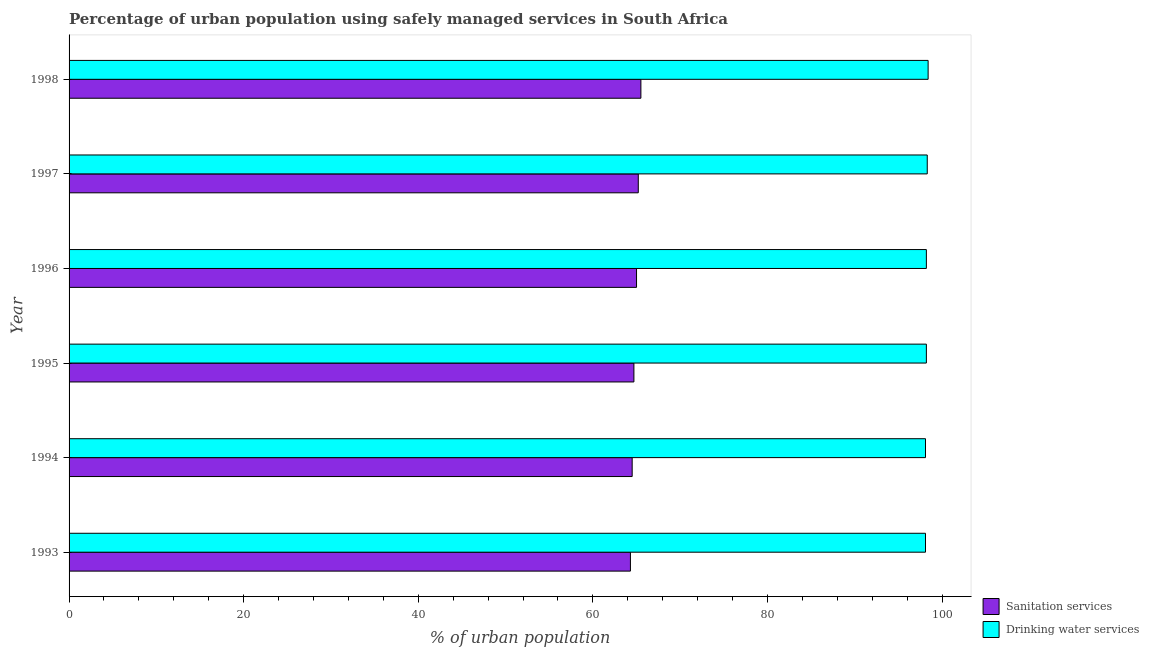How many different coloured bars are there?
Ensure brevity in your answer.  2. How many groups of bars are there?
Make the answer very short. 6. Are the number of bars on each tick of the Y-axis equal?
Offer a very short reply. Yes. How many bars are there on the 3rd tick from the bottom?
Provide a succinct answer. 2. What is the percentage of urban population who used sanitation services in 1998?
Ensure brevity in your answer.  65.5. Across all years, what is the maximum percentage of urban population who used sanitation services?
Your answer should be compact. 65.5. Across all years, what is the minimum percentage of urban population who used sanitation services?
Your answer should be very brief. 64.3. In which year was the percentage of urban population who used drinking water services maximum?
Offer a very short reply. 1998. In which year was the percentage of urban population who used sanitation services minimum?
Ensure brevity in your answer.  1993. What is the total percentage of urban population who used sanitation services in the graph?
Ensure brevity in your answer.  389.2. What is the difference between the percentage of urban population who used sanitation services in 1995 and the percentage of urban population who used drinking water services in 1996?
Make the answer very short. -33.5. What is the average percentage of urban population who used sanitation services per year?
Your answer should be very brief. 64.87. In the year 1996, what is the difference between the percentage of urban population who used sanitation services and percentage of urban population who used drinking water services?
Offer a terse response. -33.2. Is the difference between the percentage of urban population who used sanitation services in 1993 and 1998 greater than the difference between the percentage of urban population who used drinking water services in 1993 and 1998?
Your answer should be very brief. No. What is the difference between the highest and the second highest percentage of urban population who used drinking water services?
Provide a succinct answer. 0.1. What is the difference between the highest and the lowest percentage of urban population who used drinking water services?
Offer a terse response. 0.3. In how many years, is the percentage of urban population who used sanitation services greater than the average percentage of urban population who used sanitation services taken over all years?
Offer a very short reply. 3. Is the sum of the percentage of urban population who used drinking water services in 1994 and 1997 greater than the maximum percentage of urban population who used sanitation services across all years?
Your response must be concise. Yes. What does the 1st bar from the top in 1993 represents?
Provide a succinct answer. Drinking water services. What does the 2nd bar from the bottom in 1997 represents?
Your answer should be very brief. Drinking water services. How many bars are there?
Your answer should be compact. 12. How many years are there in the graph?
Your answer should be very brief. 6. Are the values on the major ticks of X-axis written in scientific E-notation?
Ensure brevity in your answer.  No. How many legend labels are there?
Your response must be concise. 2. What is the title of the graph?
Ensure brevity in your answer.  Percentage of urban population using safely managed services in South Africa. Does "Imports" appear as one of the legend labels in the graph?
Your answer should be very brief. No. What is the label or title of the X-axis?
Make the answer very short. % of urban population. What is the label or title of the Y-axis?
Give a very brief answer. Year. What is the % of urban population in Sanitation services in 1993?
Make the answer very short. 64.3. What is the % of urban population in Drinking water services in 1993?
Provide a short and direct response. 98.1. What is the % of urban population in Sanitation services in 1994?
Your response must be concise. 64.5. What is the % of urban population in Drinking water services in 1994?
Your response must be concise. 98.1. What is the % of urban population of Sanitation services in 1995?
Give a very brief answer. 64.7. What is the % of urban population in Drinking water services in 1995?
Keep it short and to the point. 98.2. What is the % of urban population in Sanitation services in 1996?
Your answer should be very brief. 65. What is the % of urban population in Drinking water services in 1996?
Make the answer very short. 98.2. What is the % of urban population of Sanitation services in 1997?
Your answer should be very brief. 65.2. What is the % of urban population in Drinking water services in 1997?
Keep it short and to the point. 98.3. What is the % of urban population in Sanitation services in 1998?
Make the answer very short. 65.5. What is the % of urban population in Drinking water services in 1998?
Offer a terse response. 98.4. Across all years, what is the maximum % of urban population in Sanitation services?
Give a very brief answer. 65.5. Across all years, what is the maximum % of urban population of Drinking water services?
Offer a very short reply. 98.4. Across all years, what is the minimum % of urban population of Sanitation services?
Your answer should be compact. 64.3. Across all years, what is the minimum % of urban population in Drinking water services?
Your response must be concise. 98.1. What is the total % of urban population in Sanitation services in the graph?
Your answer should be very brief. 389.2. What is the total % of urban population of Drinking water services in the graph?
Provide a succinct answer. 589.3. What is the difference between the % of urban population of Drinking water services in 1993 and that in 1994?
Your answer should be compact. 0. What is the difference between the % of urban population in Sanitation services in 1993 and that in 1995?
Your answer should be very brief. -0.4. What is the difference between the % of urban population in Drinking water services in 1993 and that in 1995?
Your answer should be very brief. -0.1. What is the difference between the % of urban population of Sanitation services in 1993 and that in 1996?
Give a very brief answer. -0.7. What is the difference between the % of urban population of Drinking water services in 1993 and that in 1996?
Your answer should be compact. -0.1. What is the difference between the % of urban population of Sanitation services in 1993 and that in 1997?
Offer a terse response. -0.9. What is the difference between the % of urban population in Sanitation services in 1993 and that in 1998?
Your response must be concise. -1.2. What is the difference between the % of urban population of Drinking water services in 1993 and that in 1998?
Your answer should be very brief. -0.3. What is the difference between the % of urban population in Sanitation services in 1994 and that in 1995?
Give a very brief answer. -0.2. What is the difference between the % of urban population in Drinking water services in 1994 and that in 1995?
Ensure brevity in your answer.  -0.1. What is the difference between the % of urban population in Drinking water services in 1994 and that in 1996?
Give a very brief answer. -0.1. What is the difference between the % of urban population of Sanitation services in 1994 and that in 1997?
Give a very brief answer. -0.7. What is the difference between the % of urban population in Drinking water services in 1994 and that in 1997?
Offer a terse response. -0.2. What is the difference between the % of urban population in Drinking water services in 1995 and that in 1997?
Your response must be concise. -0.1. What is the difference between the % of urban population of Sanitation services in 1996 and that in 1997?
Provide a succinct answer. -0.2. What is the difference between the % of urban population in Drinking water services in 1996 and that in 1997?
Ensure brevity in your answer.  -0.1. What is the difference between the % of urban population in Sanitation services in 1996 and that in 1998?
Make the answer very short. -0.5. What is the difference between the % of urban population of Drinking water services in 1997 and that in 1998?
Ensure brevity in your answer.  -0.1. What is the difference between the % of urban population of Sanitation services in 1993 and the % of urban population of Drinking water services in 1994?
Your answer should be compact. -33.8. What is the difference between the % of urban population of Sanitation services in 1993 and the % of urban population of Drinking water services in 1995?
Offer a very short reply. -33.9. What is the difference between the % of urban population in Sanitation services in 1993 and the % of urban population in Drinking water services in 1996?
Your response must be concise. -33.9. What is the difference between the % of urban population in Sanitation services in 1993 and the % of urban population in Drinking water services in 1997?
Provide a succinct answer. -34. What is the difference between the % of urban population of Sanitation services in 1993 and the % of urban population of Drinking water services in 1998?
Give a very brief answer. -34.1. What is the difference between the % of urban population of Sanitation services in 1994 and the % of urban population of Drinking water services in 1995?
Your answer should be compact. -33.7. What is the difference between the % of urban population in Sanitation services in 1994 and the % of urban population in Drinking water services in 1996?
Ensure brevity in your answer.  -33.7. What is the difference between the % of urban population in Sanitation services in 1994 and the % of urban population in Drinking water services in 1997?
Your response must be concise. -33.8. What is the difference between the % of urban population in Sanitation services in 1994 and the % of urban population in Drinking water services in 1998?
Keep it short and to the point. -33.9. What is the difference between the % of urban population of Sanitation services in 1995 and the % of urban population of Drinking water services in 1996?
Your response must be concise. -33.5. What is the difference between the % of urban population of Sanitation services in 1995 and the % of urban population of Drinking water services in 1997?
Your answer should be compact. -33.6. What is the difference between the % of urban population in Sanitation services in 1995 and the % of urban population in Drinking water services in 1998?
Make the answer very short. -33.7. What is the difference between the % of urban population in Sanitation services in 1996 and the % of urban population in Drinking water services in 1997?
Your answer should be compact. -33.3. What is the difference between the % of urban population of Sanitation services in 1996 and the % of urban population of Drinking water services in 1998?
Provide a short and direct response. -33.4. What is the difference between the % of urban population in Sanitation services in 1997 and the % of urban population in Drinking water services in 1998?
Keep it short and to the point. -33.2. What is the average % of urban population of Sanitation services per year?
Your response must be concise. 64.87. What is the average % of urban population in Drinking water services per year?
Your response must be concise. 98.22. In the year 1993, what is the difference between the % of urban population of Sanitation services and % of urban population of Drinking water services?
Your answer should be very brief. -33.8. In the year 1994, what is the difference between the % of urban population in Sanitation services and % of urban population in Drinking water services?
Ensure brevity in your answer.  -33.6. In the year 1995, what is the difference between the % of urban population of Sanitation services and % of urban population of Drinking water services?
Give a very brief answer. -33.5. In the year 1996, what is the difference between the % of urban population in Sanitation services and % of urban population in Drinking water services?
Provide a succinct answer. -33.2. In the year 1997, what is the difference between the % of urban population of Sanitation services and % of urban population of Drinking water services?
Make the answer very short. -33.1. In the year 1998, what is the difference between the % of urban population of Sanitation services and % of urban population of Drinking water services?
Offer a very short reply. -32.9. What is the ratio of the % of urban population in Sanitation services in 1993 to that in 1994?
Your answer should be compact. 1. What is the ratio of the % of urban population in Sanitation services in 1993 to that in 1996?
Provide a short and direct response. 0.99. What is the ratio of the % of urban population in Drinking water services in 1993 to that in 1996?
Make the answer very short. 1. What is the ratio of the % of urban population of Sanitation services in 1993 to that in 1997?
Provide a short and direct response. 0.99. What is the ratio of the % of urban population of Sanitation services in 1993 to that in 1998?
Provide a succinct answer. 0.98. What is the ratio of the % of urban population of Drinking water services in 1993 to that in 1998?
Keep it short and to the point. 1. What is the ratio of the % of urban population of Sanitation services in 1994 to that in 1995?
Make the answer very short. 1. What is the ratio of the % of urban population in Sanitation services in 1994 to that in 1996?
Keep it short and to the point. 0.99. What is the ratio of the % of urban population of Drinking water services in 1994 to that in 1996?
Provide a short and direct response. 1. What is the ratio of the % of urban population in Sanitation services in 1994 to that in 1997?
Make the answer very short. 0.99. What is the ratio of the % of urban population of Drinking water services in 1994 to that in 1997?
Your answer should be very brief. 1. What is the ratio of the % of urban population of Sanitation services in 1994 to that in 1998?
Your answer should be very brief. 0.98. What is the ratio of the % of urban population in Drinking water services in 1994 to that in 1998?
Your response must be concise. 1. What is the ratio of the % of urban population of Sanitation services in 1995 to that in 1996?
Provide a succinct answer. 1. What is the ratio of the % of urban population of Drinking water services in 1995 to that in 1997?
Keep it short and to the point. 1. What is the ratio of the % of urban population of Sanitation services in 1996 to that in 1997?
Ensure brevity in your answer.  1. What is the ratio of the % of urban population in Sanitation services in 1997 to that in 1998?
Make the answer very short. 1. What is the ratio of the % of urban population of Drinking water services in 1997 to that in 1998?
Keep it short and to the point. 1. What is the difference between the highest and the second highest % of urban population of Sanitation services?
Your answer should be very brief. 0.3. What is the difference between the highest and the lowest % of urban population of Sanitation services?
Your answer should be very brief. 1.2. What is the difference between the highest and the lowest % of urban population of Drinking water services?
Your answer should be very brief. 0.3. 